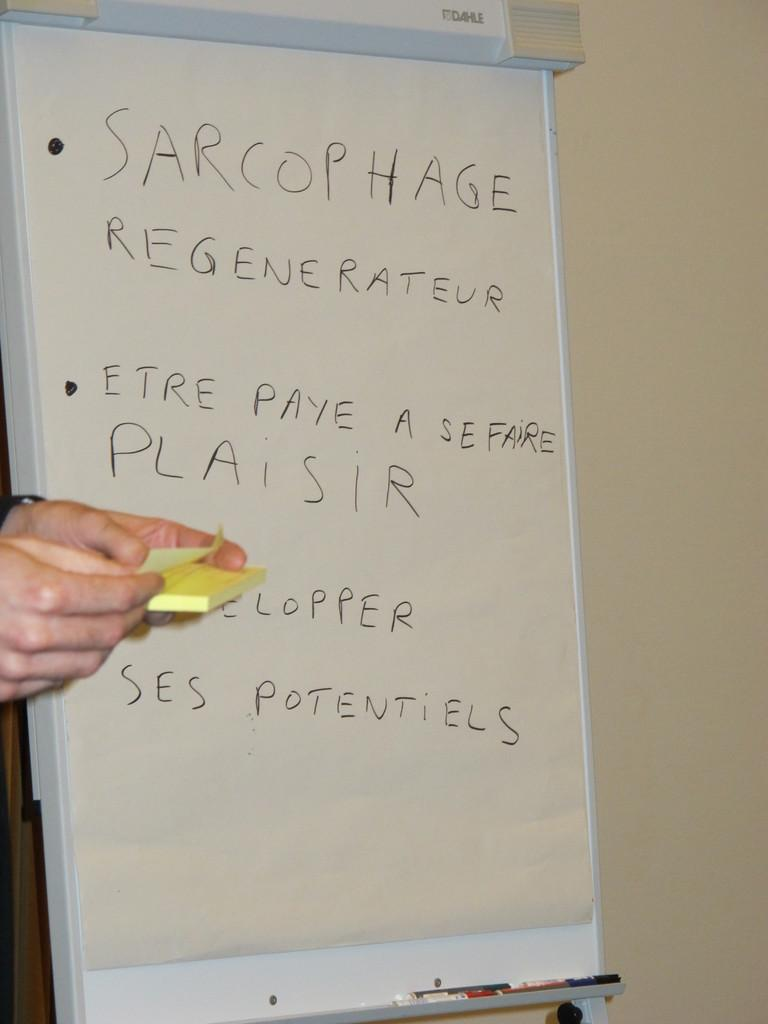<image>
Give a short and clear explanation of the subsequent image. Sarcophage regenereateur written on a white board with marker 